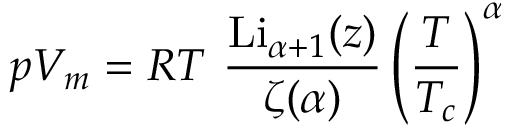<formula> <loc_0><loc_0><loc_500><loc_500>p V _ { m } = R T { \frac { { L i } _ { \alpha + 1 } ( z ) } { \zeta ( \alpha ) } } \left ( { \frac { T } { T _ { c } } } \right ) ^ { \alpha }</formula> 